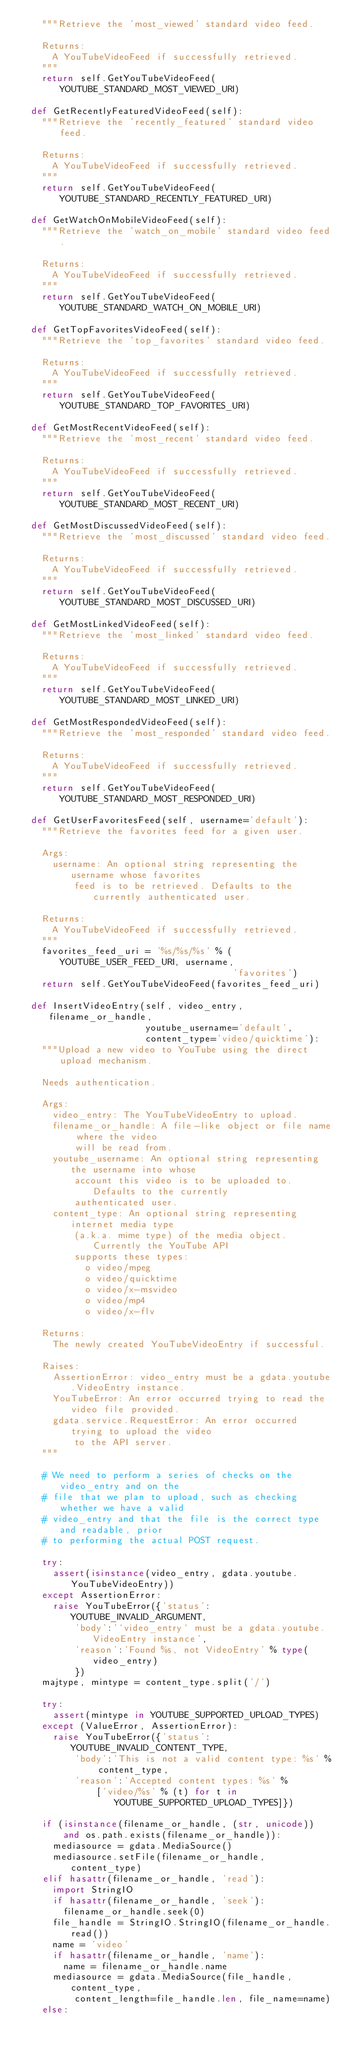Convert code to text. <code><loc_0><loc_0><loc_500><loc_500><_Python_>    """Retrieve the 'most_viewed' standard video feed.

    Returns:
      A YouTubeVideoFeed if successfully retrieved.
    """
    return self.GetYouTubeVideoFeed(YOUTUBE_STANDARD_MOST_VIEWED_URI)

  def GetRecentlyFeaturedVideoFeed(self):
    """Retrieve the 'recently_featured' standard video feed.

    Returns:
      A YouTubeVideoFeed if successfully retrieved.
    """
    return self.GetYouTubeVideoFeed(YOUTUBE_STANDARD_RECENTLY_FEATURED_URI)

  def GetWatchOnMobileVideoFeed(self):
    """Retrieve the 'watch_on_mobile' standard video feed.

    Returns:
      A YouTubeVideoFeed if successfully retrieved.
    """
    return self.GetYouTubeVideoFeed(YOUTUBE_STANDARD_WATCH_ON_MOBILE_URI)

  def GetTopFavoritesVideoFeed(self):
    """Retrieve the 'top_favorites' standard video feed.

    Returns:
      A YouTubeVideoFeed if successfully retrieved.
    """
    return self.GetYouTubeVideoFeed(YOUTUBE_STANDARD_TOP_FAVORITES_URI)

  def GetMostRecentVideoFeed(self):
    """Retrieve the 'most_recent' standard video feed.

    Returns:
      A YouTubeVideoFeed if successfully retrieved.
    """
    return self.GetYouTubeVideoFeed(YOUTUBE_STANDARD_MOST_RECENT_URI)

  def GetMostDiscussedVideoFeed(self):
    """Retrieve the 'most_discussed' standard video feed.

    Returns:
      A YouTubeVideoFeed if successfully retrieved.
    """
    return self.GetYouTubeVideoFeed(YOUTUBE_STANDARD_MOST_DISCUSSED_URI)

  def GetMostLinkedVideoFeed(self):
    """Retrieve the 'most_linked' standard video feed.

    Returns:
      A YouTubeVideoFeed if successfully retrieved.
    """
    return self.GetYouTubeVideoFeed(YOUTUBE_STANDARD_MOST_LINKED_URI)

  def GetMostRespondedVideoFeed(self):
    """Retrieve the 'most_responded' standard video feed.

    Returns:
      A YouTubeVideoFeed if successfully retrieved.
    """
    return self.GetYouTubeVideoFeed(YOUTUBE_STANDARD_MOST_RESPONDED_URI)

  def GetUserFavoritesFeed(self, username='default'):
    """Retrieve the favorites feed for a given user.

    Args:
      username: An optional string representing the username whose favorites
          feed is to be retrieved. Defaults to the currently authenticated user.

    Returns:
      A YouTubeVideoFeed if successfully retrieved.
    """
    favorites_feed_uri = '%s/%s/%s' % (YOUTUBE_USER_FEED_URI, username,
                                       'favorites')
    return self.GetYouTubeVideoFeed(favorites_feed_uri)

  def InsertVideoEntry(self, video_entry, filename_or_handle,
                       youtube_username='default',
                       content_type='video/quicktime'):
    """Upload a new video to YouTube using the direct upload mechanism.

    Needs authentication.

    Args:
      video_entry: The YouTubeVideoEntry to upload.
      filename_or_handle: A file-like object or file name where the video
          will be read from.
      youtube_username: An optional string representing the username into whose
          account this video is to be uploaded to. Defaults to the currently
          authenticated user.
      content_type: An optional string representing internet media type
          (a.k.a. mime type) of the media object. Currently the YouTube API
          supports these types:
            o video/mpeg
            o video/quicktime
            o video/x-msvideo
            o video/mp4
            o video/x-flv

    Returns:
      The newly created YouTubeVideoEntry if successful.

    Raises:
      AssertionError: video_entry must be a gdata.youtube.VideoEntry instance.
      YouTubeError: An error occurred trying to read the video file provided.
      gdata.service.RequestError: An error occurred trying to upload the video
          to the API server.
    """

    # We need to perform a series of checks on the video_entry and on the
    # file that we plan to upload, such as checking whether we have a valid
    # video_entry and that the file is the correct type and readable, prior
    # to performing the actual POST request.

    try:
      assert(isinstance(video_entry, gdata.youtube.YouTubeVideoEntry))
    except AssertionError:
      raise YouTubeError({'status':YOUTUBE_INVALID_ARGUMENT,
          'body':'`video_entry` must be a gdata.youtube.VideoEntry instance',
          'reason':'Found %s, not VideoEntry' % type(video_entry)
          })
    majtype, mintype = content_type.split('/')

    try:
      assert(mintype in YOUTUBE_SUPPORTED_UPLOAD_TYPES)
    except (ValueError, AssertionError):
      raise YouTubeError({'status':YOUTUBE_INVALID_CONTENT_TYPE,
          'body':'This is not a valid content type: %s' % content_type,
          'reason':'Accepted content types: %s' %
              ['video/%s' % (t) for t in YOUTUBE_SUPPORTED_UPLOAD_TYPES]})

    if (isinstance(filename_or_handle, (str, unicode)) 
        and os.path.exists(filename_or_handle)):
      mediasource = gdata.MediaSource()
      mediasource.setFile(filename_or_handle, content_type)
    elif hasattr(filename_or_handle, 'read'):
      import StringIO
      if hasattr(filename_or_handle, 'seek'):
        filename_or_handle.seek(0)
      file_handle = StringIO.StringIO(filename_or_handle.read())
      name = 'video'
      if hasattr(filename_or_handle, 'name'):
        name = filename_or_handle.name
      mediasource = gdata.MediaSource(file_handle, content_type,
          content_length=file_handle.len, file_name=name)
    else:</code> 